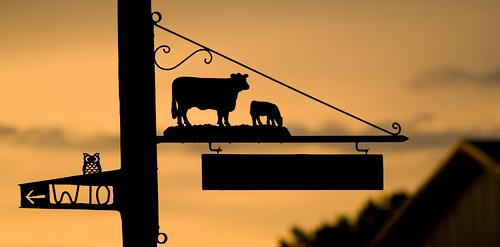Provide a brief overview of the primary elements found in the image. The image contains metal cows, white clouds in blue sky, signs with various designs and text, a rooftop, trees, and a yellow sky in the background. Analyze the emotions or sentiment conveyed by the image. The image conveys a calm and serene sentiment with the combination of sky, clouds, and nature elements such as trees and cows. How many metal cows appear in the image? There are three metal cows in the image. Count the number of clouds visible in the image. There are ten cloud formations in the image. Count the number of white clouds present in the blue sky. 8 Segment the existing clouds in the image. White clouds in blue sky, clouds in the sky at sunset, gray clouds in the yellow sky. How many times do cow designs appear on the image? 6 Describe the interaction between the metal cows and the sign. The metal cows are part of the sign's design, attached to it. Are there any objects interacting with the metal cows? No, the metal cows are part of the sign and not interacting with other objects. Can you find a red car parked near a building in the image? No, it's not mentioned in the image. Assess the quality of the image. High quality with clear objects and details. What is the color of the trees beyond the building? Green Detect any anomalies or unusual aspects in the image. No significant anomalies detected. Identify the animals portrayed in the metal sign. Cows and an owl. Detect attributes of the metal cows on the sign. Two cows, metal material, part of the sign's design. Mention an animal other than a cow found on a metal sign. Owl Determine the sentiment conveyed by the image. Neutral. What is the shape of the arrow on the metal sign? Arrow cut into the pole. Identify any text, letters, or numbers present in the image. The word "owl" backwards on the metal sign and "w10" cut into the pole. Identify the text on the metal sign associated with the owl. The word "owl" backwards. Describe the position of the rooftop in relation to the trees. Rooftop on the right of the trees. Describe the main objects present in the image. Metal cows on a sign, white clouds in blue sky, owl sitting as part of a metal sign, green trees beyond a building, yellow sky in the background. Which color represents the sky in the background of the image? Yellow 